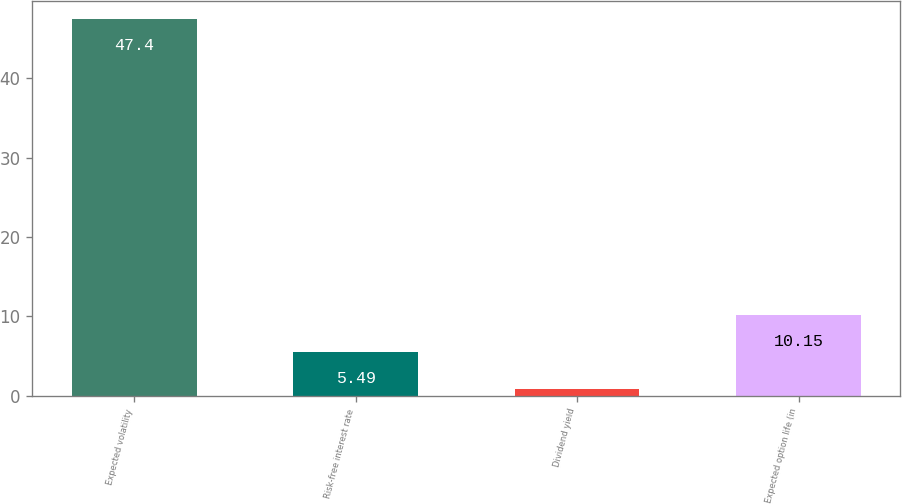<chart> <loc_0><loc_0><loc_500><loc_500><bar_chart><fcel>Expected volatility<fcel>Risk-free interest rate<fcel>Dividend yield<fcel>Expected option life (in<nl><fcel>47.4<fcel>5.49<fcel>0.83<fcel>10.15<nl></chart> 